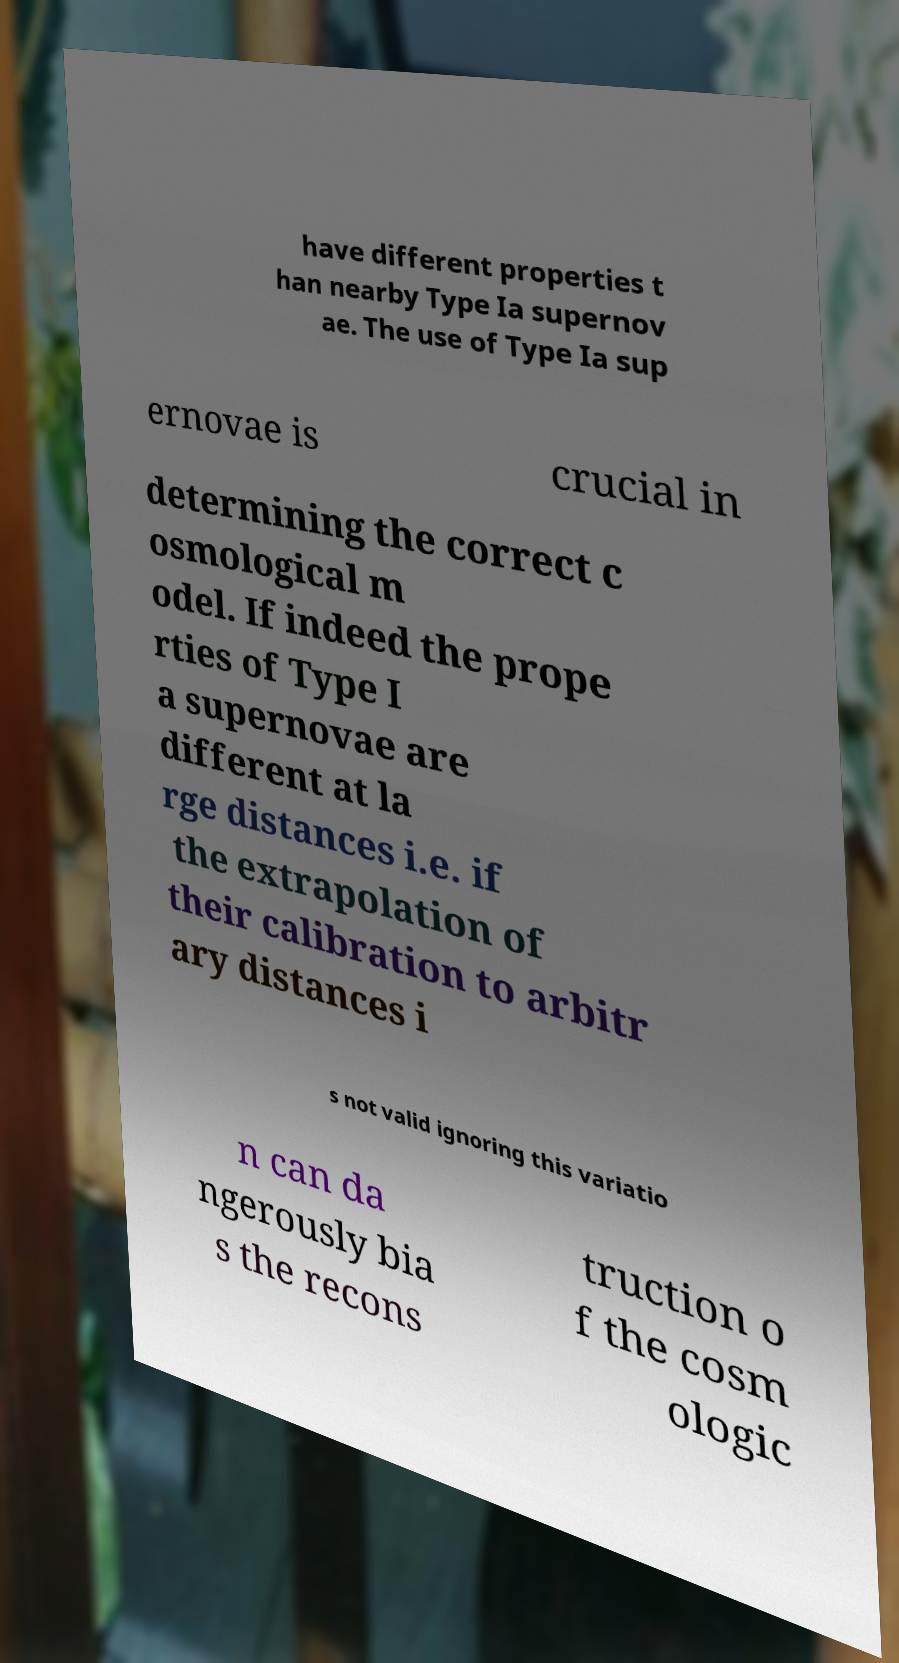Can you read and provide the text displayed in the image?This photo seems to have some interesting text. Can you extract and type it out for me? have different properties t han nearby Type Ia supernov ae. The use of Type Ia sup ernovae is crucial in determining the correct c osmological m odel. If indeed the prope rties of Type I a supernovae are different at la rge distances i.e. if the extrapolation of their calibration to arbitr ary distances i s not valid ignoring this variatio n can da ngerously bia s the recons truction o f the cosm ologic 